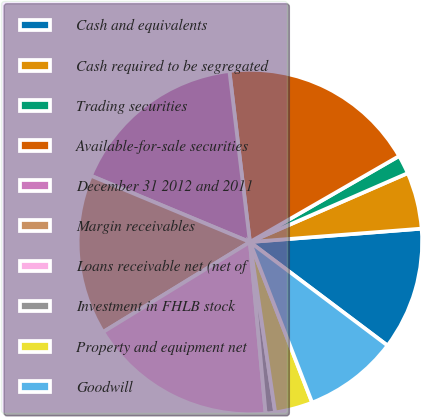Convert chart. <chart><loc_0><loc_0><loc_500><loc_500><pie_chart><fcel>Cash and equivalents<fcel>Cash required to be segregated<fcel>Trading securities<fcel>Available-for-sale securities<fcel>December 31 2012 and 2011<fcel>Margin receivables<fcel>Loans receivable net (net of<fcel>Investment in FHLB stock<fcel>Property and equipment net<fcel>Goodwill<nl><fcel>11.5%<fcel>5.31%<fcel>1.77%<fcel>18.58%<fcel>16.81%<fcel>15.04%<fcel>17.7%<fcel>0.89%<fcel>3.54%<fcel>8.85%<nl></chart> 